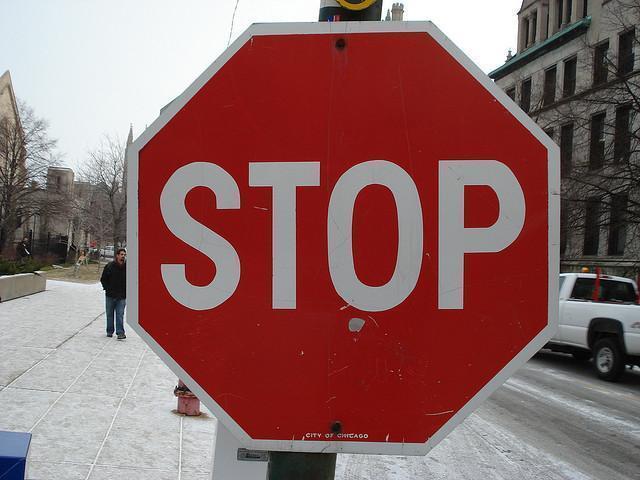This city's name comes from a Native American word for what?
Make your selection and explain in format: 'Answer: answer
Rationale: rationale.'
Options: Wind, onion, tomato, lake. Answer: onion.
Rationale: The city is chicago and comes from the algonquin language: "shikaakwa," which means onion. 